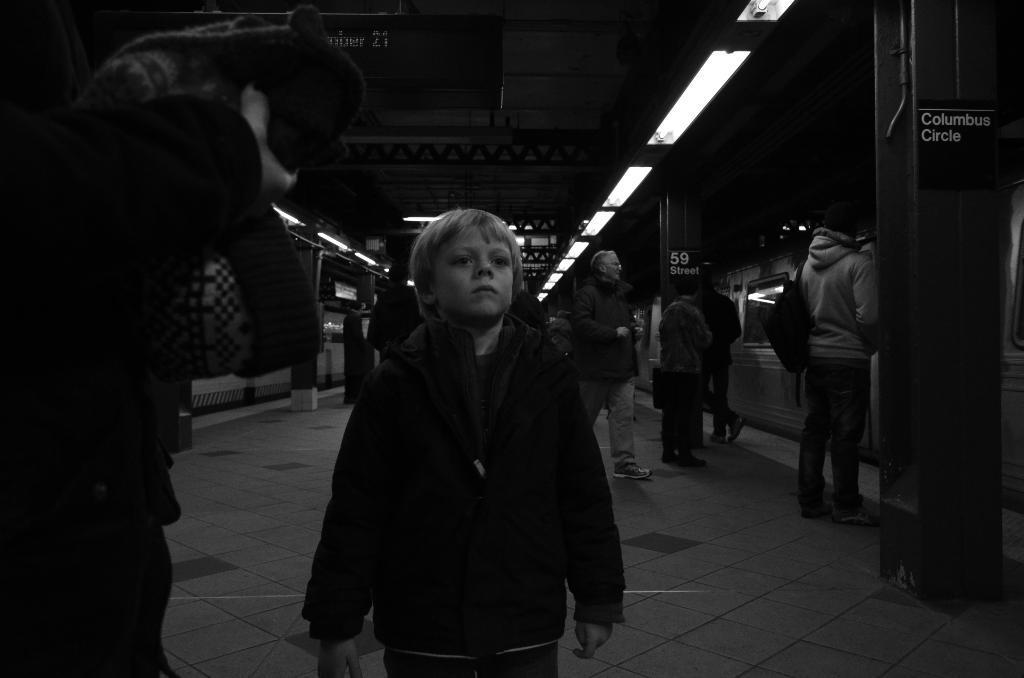How would you summarize this image in a sentence or two? This is a black and white image in which we can see there are so many people walking on the platform, beside them there is a train and some lights attached to the ceiling. 